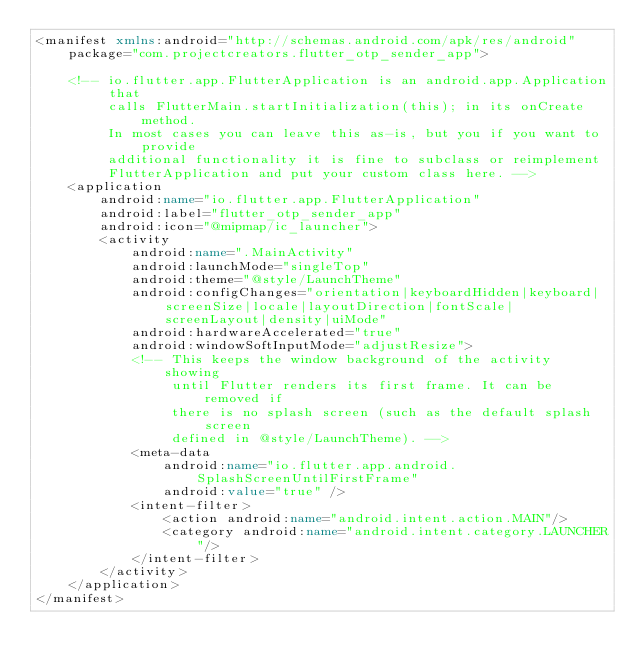Convert code to text. <code><loc_0><loc_0><loc_500><loc_500><_XML_><manifest xmlns:android="http://schemas.android.com/apk/res/android"
    package="com.projectcreators.flutter_otp_sender_app">

    <!-- io.flutter.app.FlutterApplication is an android.app.Application that
         calls FlutterMain.startInitialization(this); in its onCreate method.
         In most cases you can leave this as-is, but you if you want to provide
         additional functionality it is fine to subclass or reimplement
         FlutterApplication and put your custom class here. -->
    <application
        android:name="io.flutter.app.FlutterApplication"
        android:label="flutter_otp_sender_app"
        android:icon="@mipmap/ic_launcher">
        <activity
            android:name=".MainActivity"
            android:launchMode="singleTop"
            android:theme="@style/LaunchTheme"
            android:configChanges="orientation|keyboardHidden|keyboard|screenSize|locale|layoutDirection|fontScale|screenLayout|density|uiMode"
            android:hardwareAccelerated="true"
            android:windowSoftInputMode="adjustResize">
            <!-- This keeps the window background of the activity showing
                 until Flutter renders its first frame. It can be removed if
                 there is no splash screen (such as the default splash screen
                 defined in @style/LaunchTheme). -->
            <meta-data
                android:name="io.flutter.app.android.SplashScreenUntilFirstFrame"
                android:value="true" />
            <intent-filter>
                <action android:name="android.intent.action.MAIN"/>
                <category android:name="android.intent.category.LAUNCHER"/>
            </intent-filter>
        </activity>
    </application>
</manifest>
</code> 